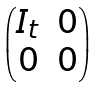Convert formula to latex. <formula><loc_0><loc_0><loc_500><loc_500>\begin{pmatrix} I _ { t } & 0 \\ 0 & 0 \end{pmatrix}</formula> 